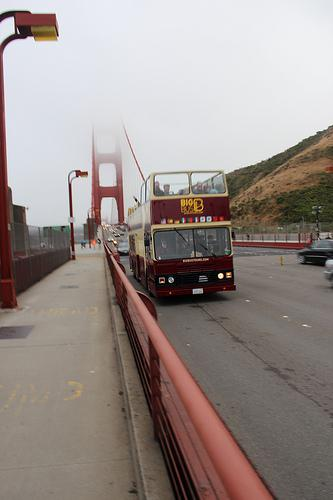Question: what color is the road?
Choices:
A. Black.
B. White.
C. Grey.
D. Yellow.
Answer with the letter. Answer: C Question: why is the photo clear?
Choices:
A. It is during the day.
B. It's sunny.
C. Lights are on.
D. Good camera work.
Answer with the letter. Answer: A 